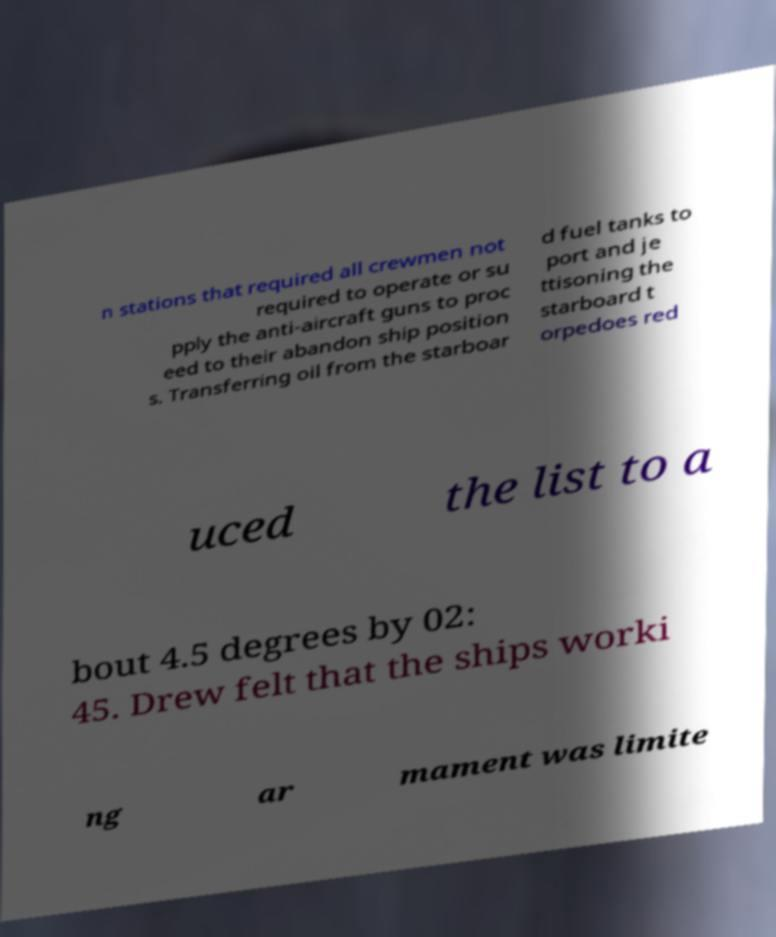Can you accurately transcribe the text from the provided image for me? n stations that required all crewmen not required to operate or su pply the anti-aircraft guns to proc eed to their abandon ship position s. Transferring oil from the starboar d fuel tanks to port and je ttisoning the starboard t orpedoes red uced the list to a bout 4.5 degrees by 02: 45. Drew felt that the ships worki ng ar mament was limite 